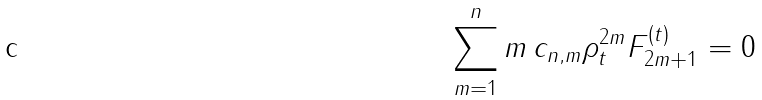Convert formula to latex. <formula><loc_0><loc_0><loc_500><loc_500>\sum _ { m = 1 } ^ { n } m \, c _ { n , m } \rho _ { t } ^ { 2 m } F _ { 2 m + 1 } ^ { ( t ) } = 0</formula> 